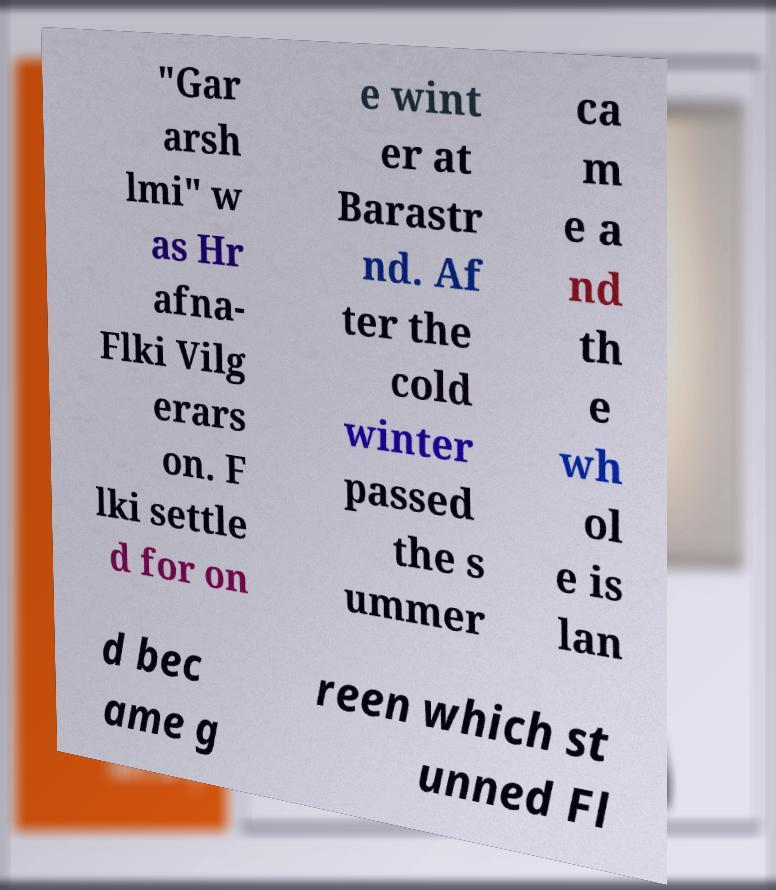Please identify and transcribe the text found in this image. "Gar arsh lmi" w as Hr afna- Flki Vilg erars on. F lki settle d for on e wint er at Barastr nd. Af ter the cold winter passed the s ummer ca m e a nd th e wh ol e is lan d bec ame g reen which st unned Fl 